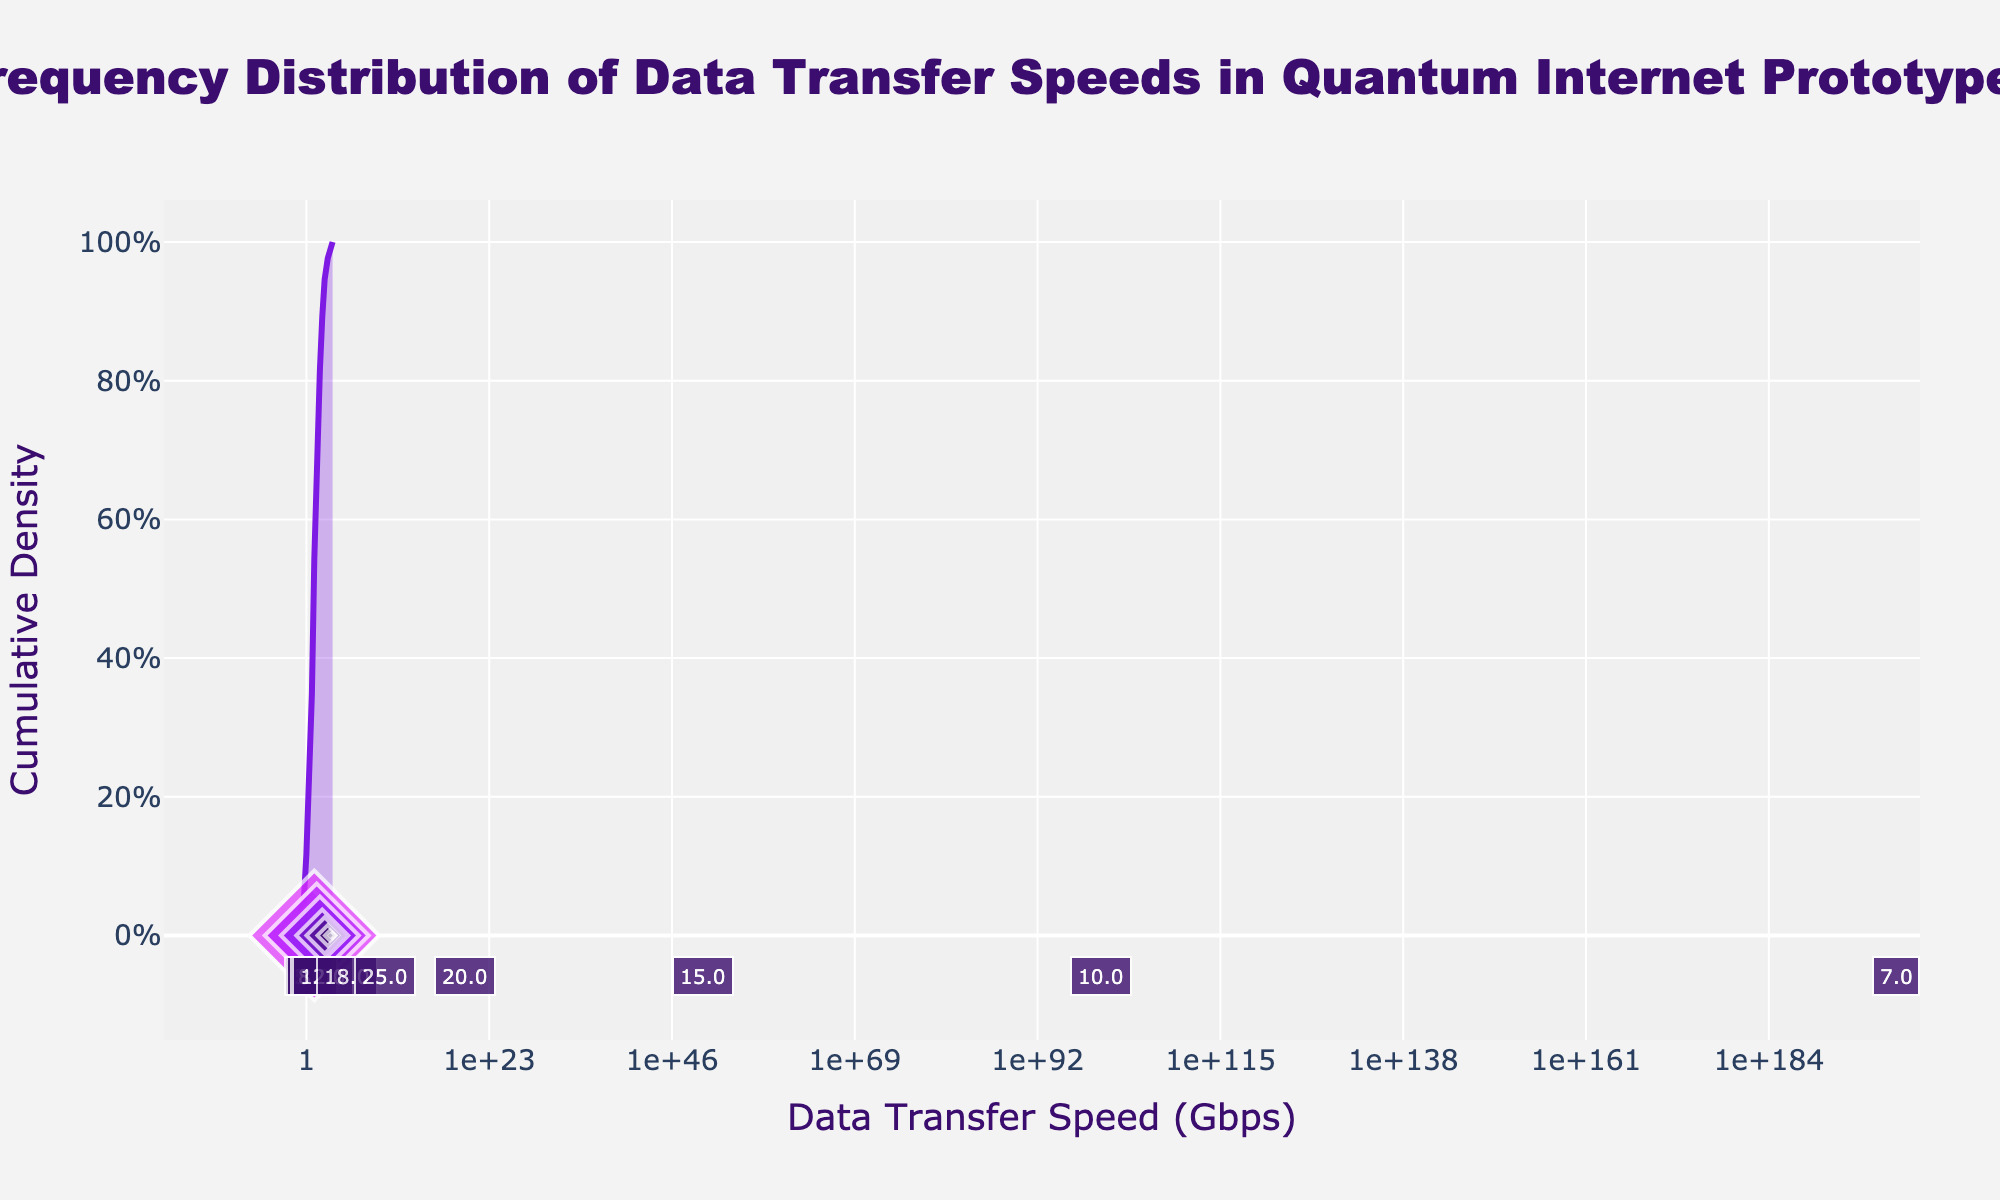What is the title of the plot? The title is prominently shown at the top of the figure. It reads, "Frequency Distribution of Data Transfer Speeds in Quantum Internet Prototypes".
Answer: Frequency Distribution of Data Transfer Speeds in Quantum Internet Prototypes How many data points are shown in the plot? Each marker on the scatter plot represents a data point. By counting the markers (diamonds), we find there are 13 data points.
Answer: 13 What is the cumulative density at a data transfer speed of 10 Gbps? Locate the transfer speed of 10 Gbps on the x-axis and trace upwards to the cumulative density curve. The density is approximately 85%.
Answer: ~85% Which data transfer speed has the highest frequency? The frequency is depicted by the size of the markers and their labels directly beneath them. The largest frequency (25) occurs at 10 Gbps.
Answer: 10 Gbps Compare the frequencies of data transfer speeds at 50 Gbps and 100 Gbps. Which is higher? The frequency labels beneath the markers indicate that the frequency at 50 Gbps is 15, while at 100 Gbps it is 10. Hence, 50 Gbps has a higher frequency.
Answer: 50 Gbps What is the sum of frequencies for data transfer speeds between 0.1 Gbps and 2 Gbps inclusive? Summing the frequencies at 0.1 (2), 0.5 (5), 1 (8), and 2 Gbps (12), we get 2 + 5 + 8 + 12 = 27.
Answer: 27 Which data transfer speeds exhibit a cumulative density above 50%? Identify the points on the x-axis where the cumulative density curve crosses the 50% mark. This occurs after 5 Gbps, so the transfer speeds that exhibit a cumulative density above 50% are above 5 Gbps.
Answer: Above 5 Gbps What is the cumulative density at the highest data transfer speed shown (2000 Gbps)? Trace the x-axis to the rightmost data transfer speed (2000 Gbps) and follow it up to the cumulative density curve. The cumulative density reaches near 100% here.
Answer: ~100% Which data transfer speed range has the most rapid increase in cumulative density? The steepest section of the cumulative density curve indicates this. Between 5 Gbps and 50 Gbps, the curve shows a significant rise in density.
Answer: 5 Gbps to 50 Gbps 